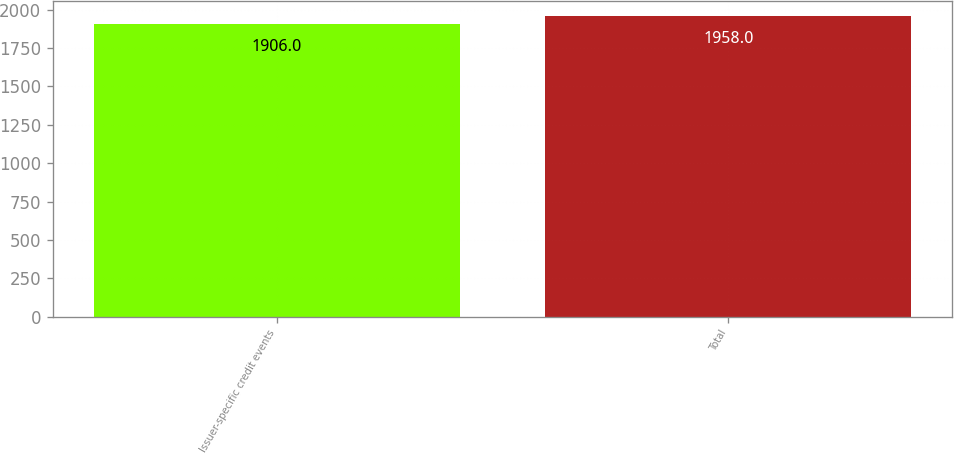Convert chart. <chart><loc_0><loc_0><loc_500><loc_500><bar_chart><fcel>Issuer-specific credit events<fcel>Total<nl><fcel>1906<fcel>1958<nl></chart> 